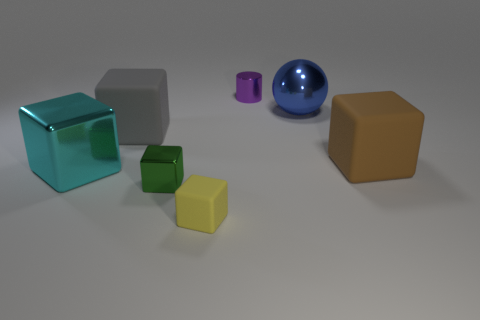Subtract 1 blocks. How many blocks are left? 4 Subtract all yellow blocks. How many blocks are left? 4 Subtract all gray matte blocks. How many blocks are left? 4 Add 2 cyan things. How many objects exist? 9 Subtract all cubes. How many objects are left? 2 Add 7 blue things. How many blue things are left? 8 Add 4 green metallic things. How many green metallic things exist? 5 Subtract 0 cyan cylinders. How many objects are left? 7 Subtract all big gray cubes. Subtract all cyan matte cubes. How many objects are left? 6 